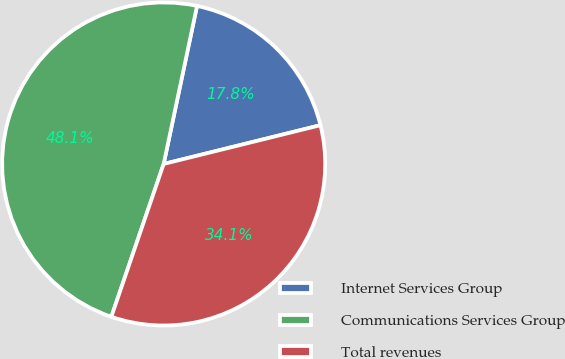<chart> <loc_0><loc_0><loc_500><loc_500><pie_chart><fcel>Internet Services Group<fcel>Communications Services Group<fcel>Total revenues<nl><fcel>17.83%<fcel>48.06%<fcel>34.11%<nl></chart> 